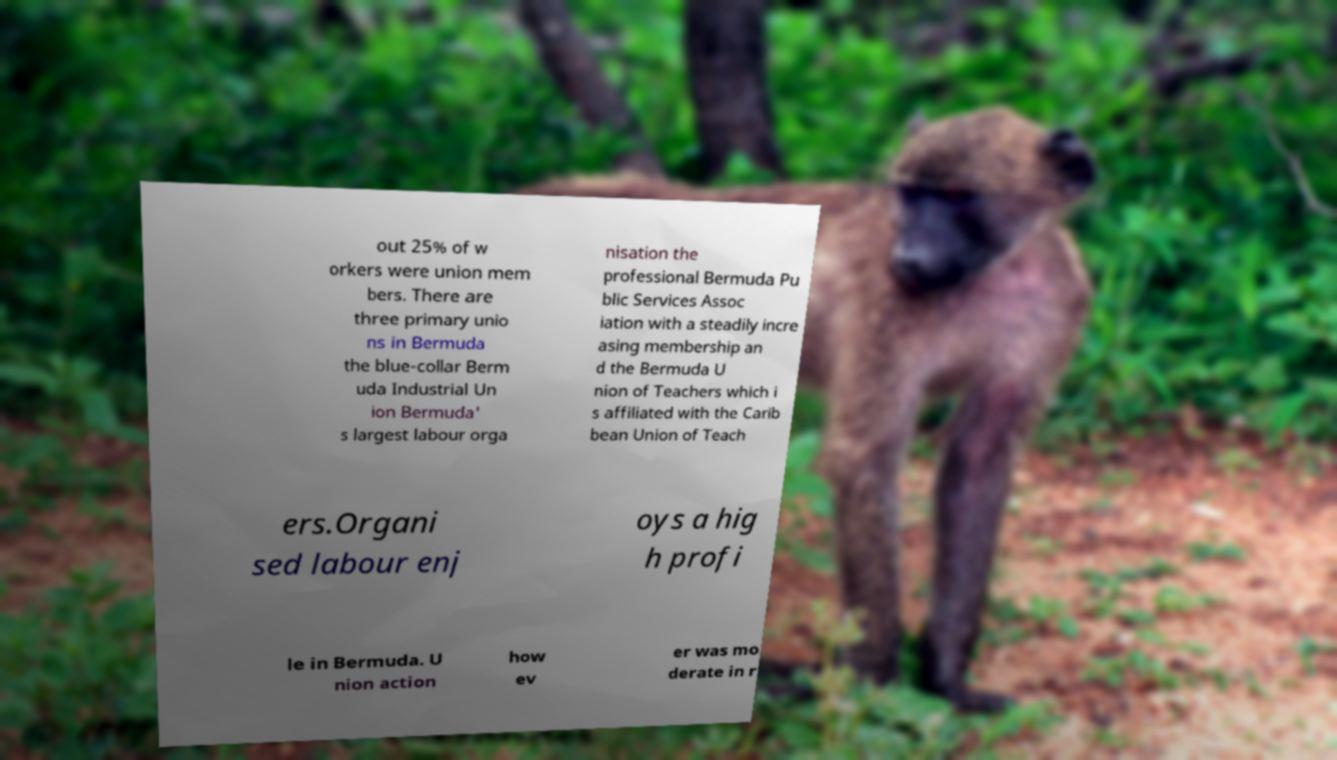Could you extract and type out the text from this image? out 25% of w orkers were union mem bers. There are three primary unio ns in Bermuda the blue-collar Berm uda Industrial Un ion Bermuda' s largest labour orga nisation the professional Bermuda Pu blic Services Assoc iation with a steadily incre asing membership an d the Bermuda U nion of Teachers which i s affiliated with the Carib bean Union of Teach ers.Organi sed labour enj oys a hig h profi le in Bermuda. U nion action how ev er was mo derate in r 